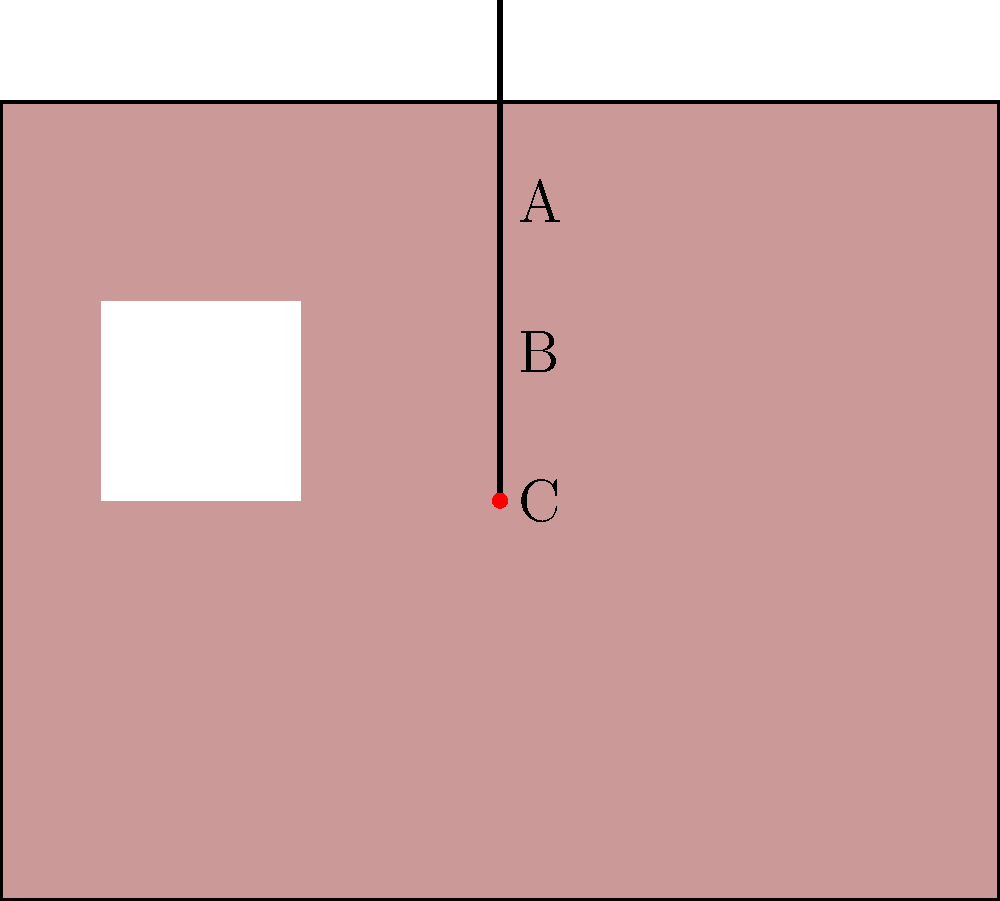As a BBQ Pit Master, you're demonstrating proper meat thermometer placement for your YouTube audience. In the cutaway steak graphic above, which point (A, B, or C) represents the ideal location for inserting the meat thermometer to accurately measure the internal temperature of a thick steak? To determine the ideal location for inserting a meat thermometer in a thick steak, let's consider the following steps:

1. Thickness: The steak in the graphic appears to be relatively thick, which is ideal for grilling and temperature measurement.

2. Thermometer placement options:
   A: Near the surface of the steak
   B: Midway between the surface and the center
   C: At the center of the steak's thickness

3. Temperature gradient: The temperature of a cooking steak varies from the outside (hottest) to the center (coolest).

4. Ideal measurement point: To accurately gauge doneness, we want to measure the coolest part of the steak, which is typically the center.

5. Avoiding bones: The thermometer should be inserted away from any bones, as they can conduct heat differently and give false readings.

6. Depth of insertion: The sensing area of most meat thermometers is in the tip, so it should be inserted deep enough to reach the center.

7. Analysis of options:
   A: Too close to the surface, would give an overestimate of internal temperature.
   B: Better than A, but still not ideal as it's not at the coolest point.
   C: Optimal position, as it's at the center of the steak's thickness.

Therefore, point C represents the ideal location for inserting the meat thermometer to accurately measure the internal temperature of a thick steak.
Answer: C 